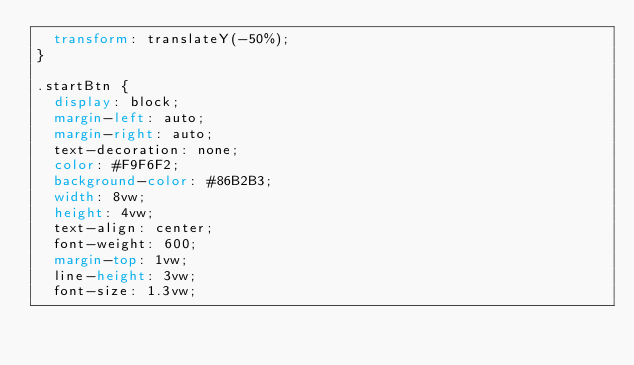<code> <loc_0><loc_0><loc_500><loc_500><_CSS_>  transform: translateY(-50%);
}

.startBtn {
  display: block;
  margin-left: auto;
  margin-right: auto;
  text-decoration: none;
  color: #F9F6F2;
  background-color: #86B2B3;
  width: 8vw;
  height: 4vw;
  text-align: center;
  font-weight: 600;
  margin-top: 1vw;
  line-height: 3vw;
  font-size: 1.3vw;</code> 